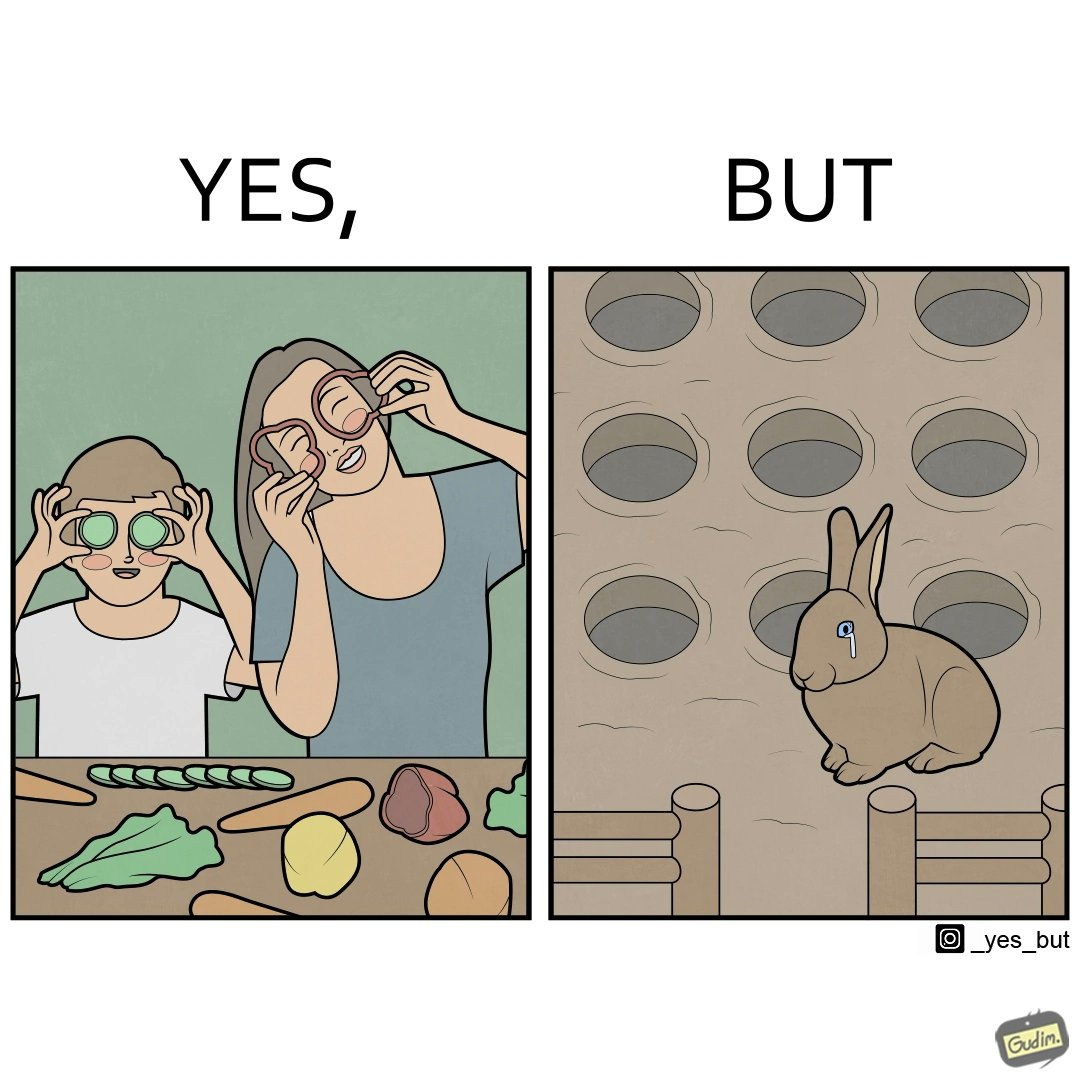Does this image contain satire or humor? Yes, this image is satirical. 